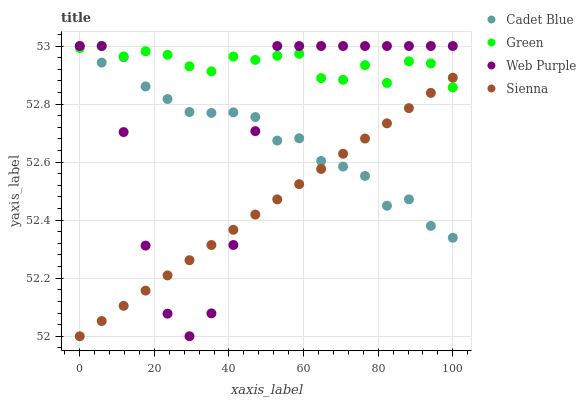Does Sienna have the minimum area under the curve?
Answer yes or no. Yes. Does Green have the maximum area under the curve?
Answer yes or no. Yes. Does Web Purple have the minimum area under the curve?
Answer yes or no. No. Does Web Purple have the maximum area under the curve?
Answer yes or no. No. Is Sienna the smoothest?
Answer yes or no. Yes. Is Web Purple the roughest?
Answer yes or no. Yes. Is Cadet Blue the smoothest?
Answer yes or no. No. Is Cadet Blue the roughest?
Answer yes or no. No. Does Sienna have the lowest value?
Answer yes or no. Yes. Does Web Purple have the lowest value?
Answer yes or no. No. Does Green have the highest value?
Answer yes or no. Yes. Does Sienna intersect Web Purple?
Answer yes or no. Yes. Is Sienna less than Web Purple?
Answer yes or no. No. Is Sienna greater than Web Purple?
Answer yes or no. No. 